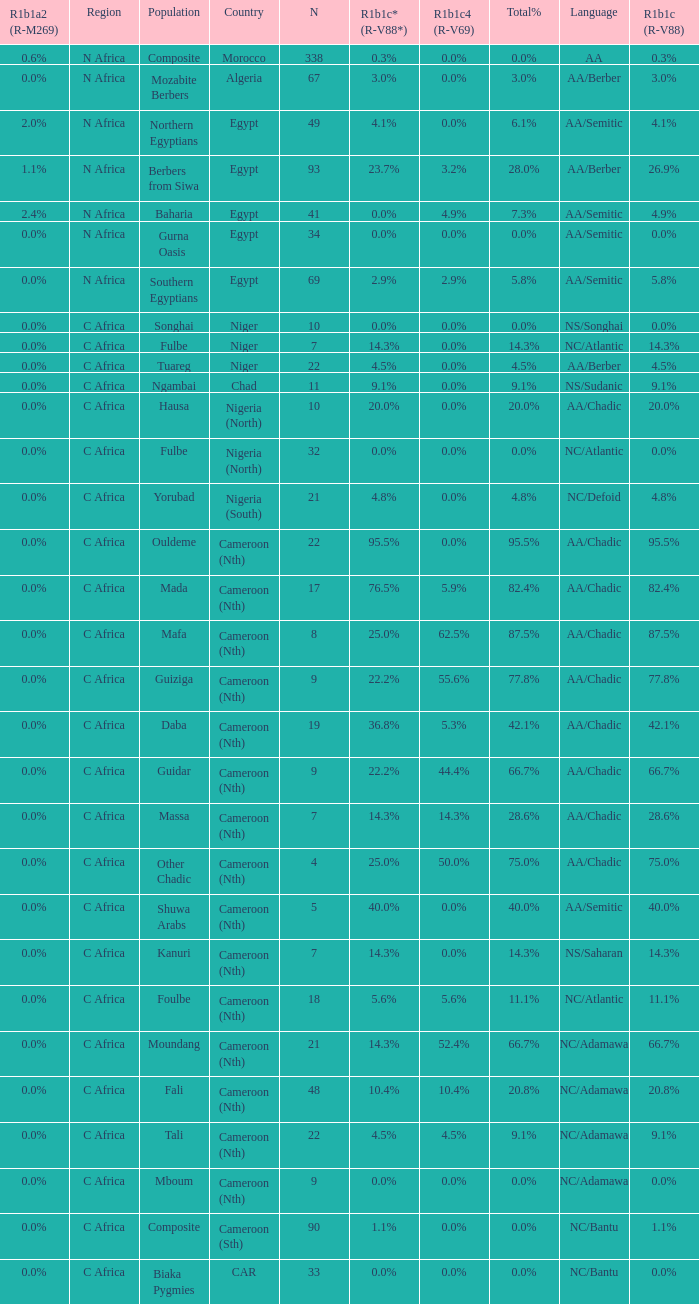What proportion is mentioned in column r1b1a2 (r-m269) for the 7 0.0%. 